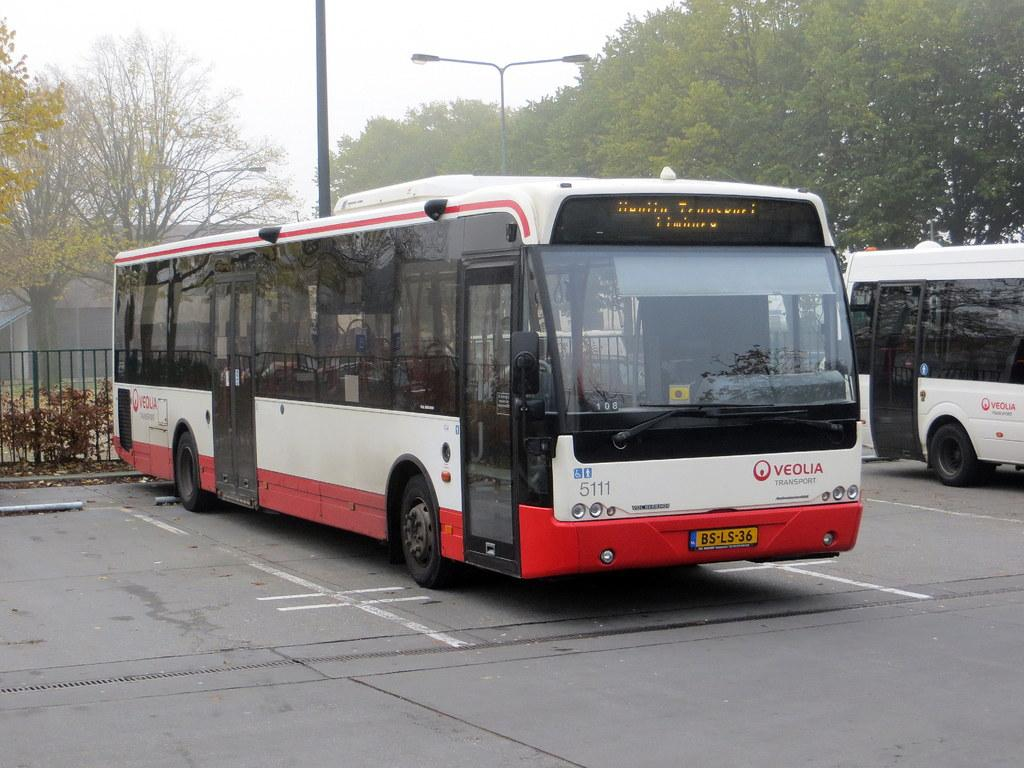<image>
Create a compact narrative representing the image presented. A red and whtie bus that is run by Veolia Transport. 